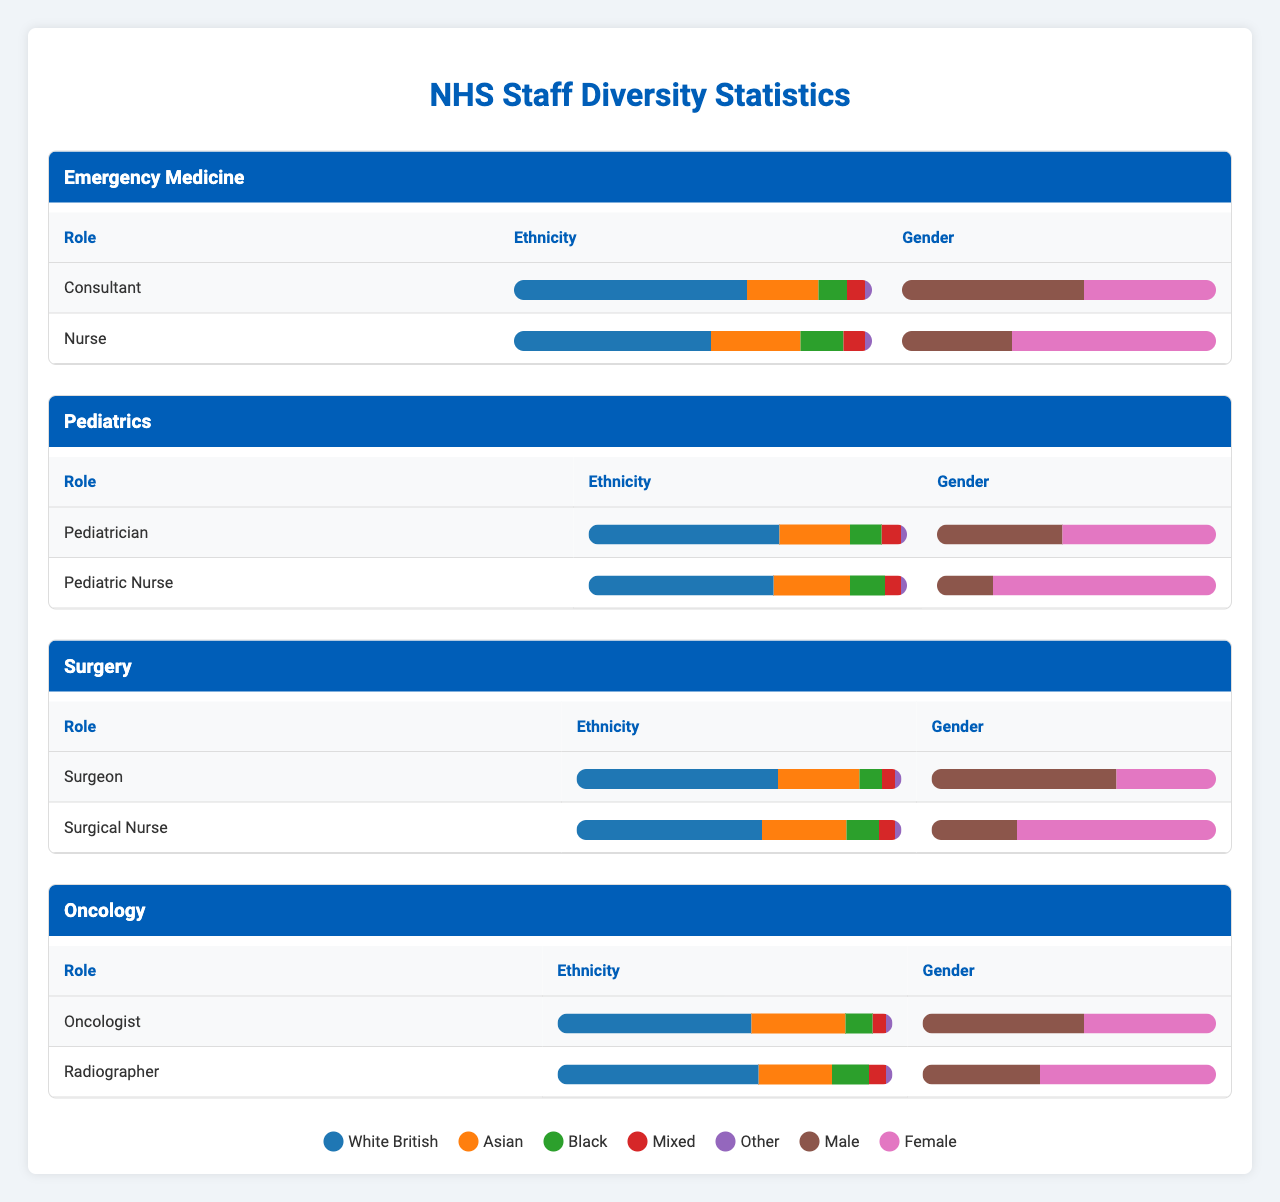What is the percentage of White British staff in the Surgical Nurse role? The table shows that for the Surgical Nurse role in the Surgery department, the percentage of White British staff is 57%.
Answer: 57% How many more male Consultants are there than female Consultants in Emergency Medicine? In Emergency Medicine, there are 58 male Consultants and 42 female Consultants. The difference is 58 - 42 = 16.
Answer: 16 Is there a higher percentage of Asian staff among Pediatric Nurses or Surgical Nurses? The percentage of Asian staff among Pediatric Nurses is 24%, while among Surgical Nurses it is 26%. Therefore, Surgical Nurses have a higher percentage of Asian staff.
Answer: Yes What is the total percentage of Male staff across all roles in Oncology? In Oncology, there are 55 male Oncologists and 40 male Radiographers. The total percentage of Male staff is (55 + 40) = 95.
Answer: 95 Which role in Pediatrics has a higher percentage of Female staff, Pediatrician or Pediatric Nurse? The Pediatrician role has 55% Female staff while the Pediatric Nurse has 80% Female staff. Since 80% > 55%, Pediatric Nurse has the higher percentage.
Answer: Pediatric Nurse What is the combined percentage of Black staff in the Surgeon and Oncologist roles? The percentage of Black staff among Surgeons is 7% and among Oncologists is 8%. Combining both gives us 7 + 8 = 15%.
Answer: 15% Which department has the highest percentage of Mixed ethnicity among staff in the Nurse roles? In Emergency Medicine, the percentage of Mixed ethnicity among Nurses is 6%. In Pediatrics, it is also 5%, and in Surgery, it is 5%. Thus, Emergency Medicine has the highest percentage of Mixed ethnicity Nurses at 6%.
Answer: Emergency Medicine What would be the average percentage of Female staff across all roles in the Surgery department? The Female percentages for Surgeon and Surgical Nurse are 35% and 70%, respectively. The average is (35 + 70) / 2 = 52.5%.
Answer: 52.5% Are there more Asian staff in the Pediatrician role compared to the Consultant role in Emergency Medicine? The Pediatrician role has 22% Asian staff while the Consultant role in Emergency Medicine has 20%. Therefore, there are more Asian staff in the Pediatrician role.
Answer: Yes What is the percentage difference in White British staff between the Consultant and Nurse roles in Emergency Medicine? The Consultant role has 65% White British staff and the Nurse role has 55%. The percentage difference is 65 - 55 = 10%.
Answer: 10% 